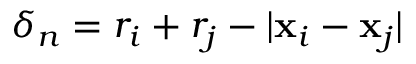Convert formula to latex. <formula><loc_0><loc_0><loc_500><loc_500>\delta _ { n } = r _ { i } + r _ { j } - | x _ { i } - x _ { j } |</formula> 